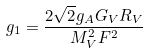Convert formula to latex. <formula><loc_0><loc_0><loc_500><loc_500>g _ { 1 } = \frac { 2 \sqrt { 2 } g _ { A } G _ { V } R _ { V } } { M _ { V } ^ { 2 } F ^ { 2 } }</formula> 